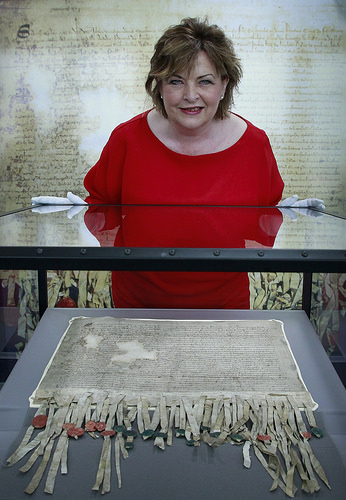<image>
Is the woman above the exhibit? Yes. The woman is positioned above the exhibit in the vertical space, higher up in the scene. 